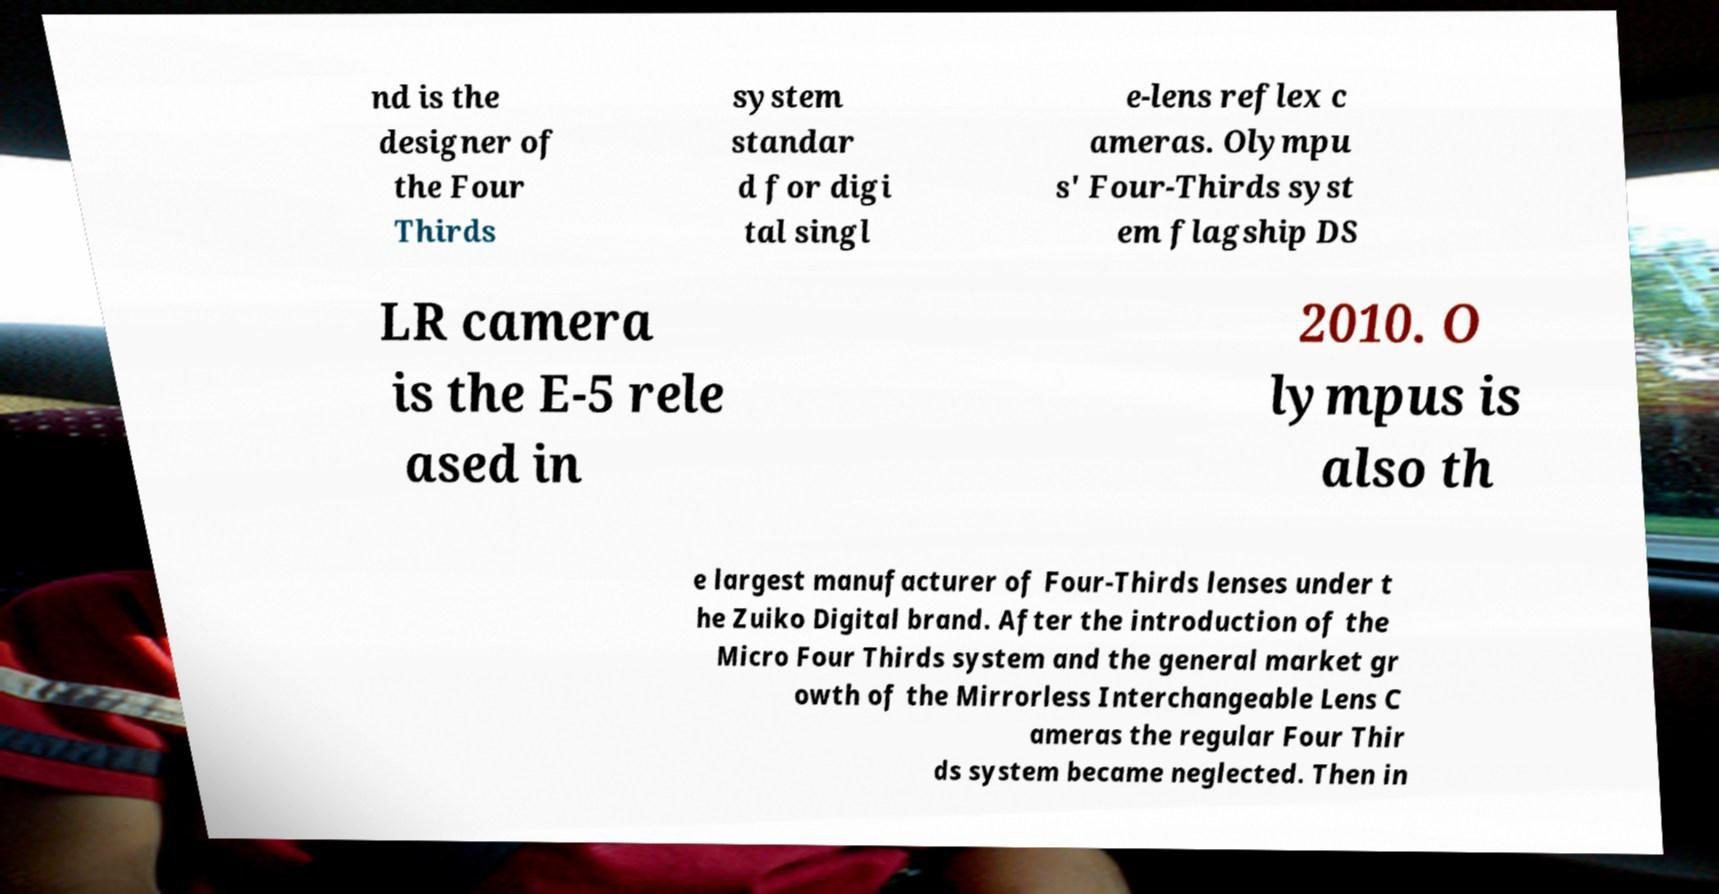I need the written content from this picture converted into text. Can you do that? nd is the designer of the Four Thirds system standar d for digi tal singl e-lens reflex c ameras. Olympu s' Four-Thirds syst em flagship DS LR camera is the E-5 rele ased in 2010. O lympus is also th e largest manufacturer of Four-Thirds lenses under t he Zuiko Digital brand. After the introduction of the Micro Four Thirds system and the general market gr owth of the Mirrorless Interchangeable Lens C ameras the regular Four Thir ds system became neglected. Then in 